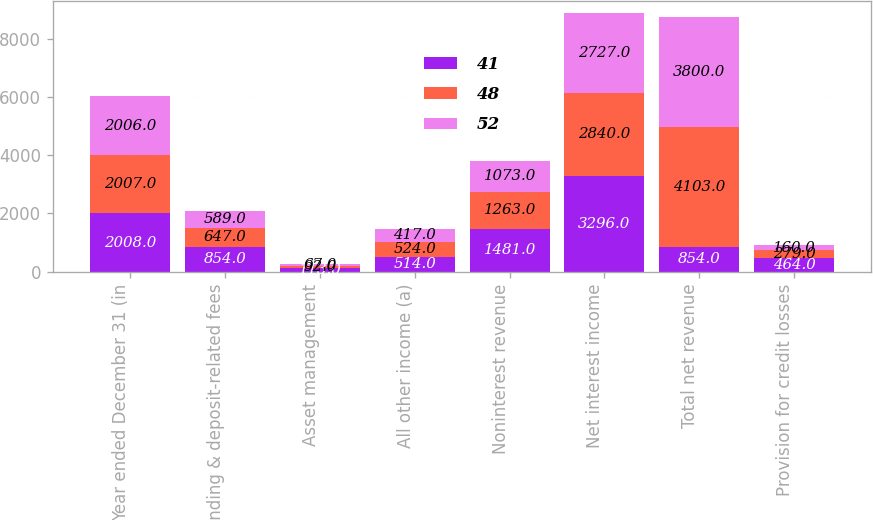<chart> <loc_0><loc_0><loc_500><loc_500><stacked_bar_chart><ecel><fcel>Year ended December 31 (in<fcel>Lending & deposit-related fees<fcel>Asset management<fcel>All other income (a)<fcel>Noninterest revenue<fcel>Net interest income<fcel>Total net revenue<fcel>Provision for credit losses<nl><fcel>41<fcel>2008<fcel>854<fcel>113<fcel>514<fcel>1481<fcel>3296<fcel>854<fcel>464<nl><fcel>48<fcel>2007<fcel>647<fcel>92<fcel>524<fcel>1263<fcel>2840<fcel>4103<fcel>279<nl><fcel>52<fcel>2006<fcel>589<fcel>67<fcel>417<fcel>1073<fcel>2727<fcel>3800<fcel>160<nl></chart> 